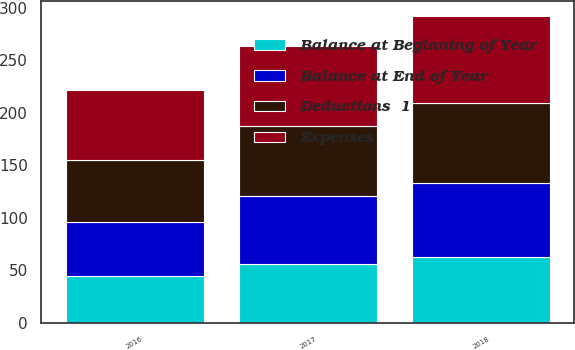<chart> <loc_0><loc_0><loc_500><loc_500><stacked_bar_chart><ecel><fcel>2018<fcel>2017<fcel>2016<nl><fcel>Deductions  1<fcel>75.7<fcel>66.5<fcel>59.3<nl><fcel>Balance at End of Year<fcel>70.3<fcel>65.1<fcel>51.5<nl><fcel>Balance at Beginning of Year<fcel>62.8<fcel>55.9<fcel>44.3<nl><fcel>Expenses<fcel>83.2<fcel>75.7<fcel>66.5<nl></chart> 